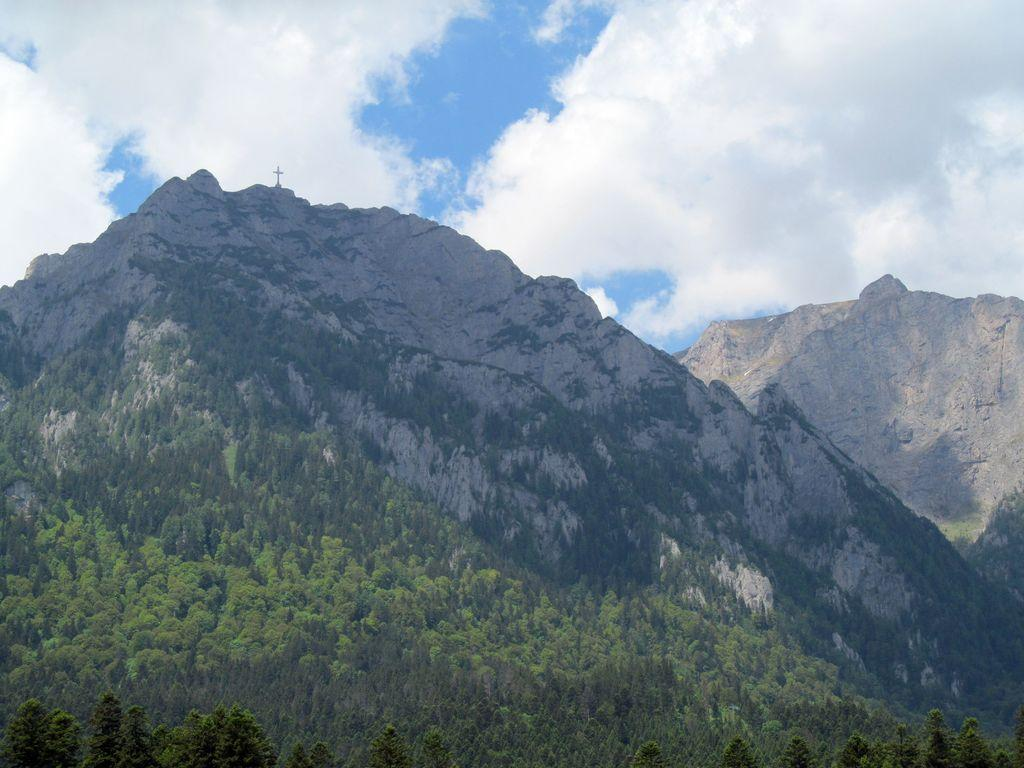What type of vegetation is in the foreground of the image? There are trees in the foreground of the image. What type of geographical feature can be seen in the background of the image? There are mountains in the background of the image. What can be seen in the sky in the image? There are clouds visible in the sky. What type of vest is being worn by the blade in the image? There is no vest or blade present in the image; it features trees in the foreground and mountains in the background. 